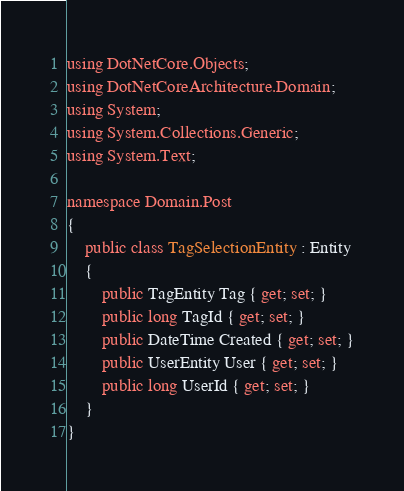<code> <loc_0><loc_0><loc_500><loc_500><_C#_>using DotNetCore.Objects;
using DotNetCoreArchitecture.Domain;
using System;
using System.Collections.Generic;
using System.Text;

namespace Domain.Post
{
    public class TagSelectionEntity : Entity
    {
        public TagEntity Tag { get; set; }
        public long TagId { get; set; }
        public DateTime Created { get; set; }
        public UserEntity User { get; set; }
        public long UserId { get; set; }
    }
}
</code> 